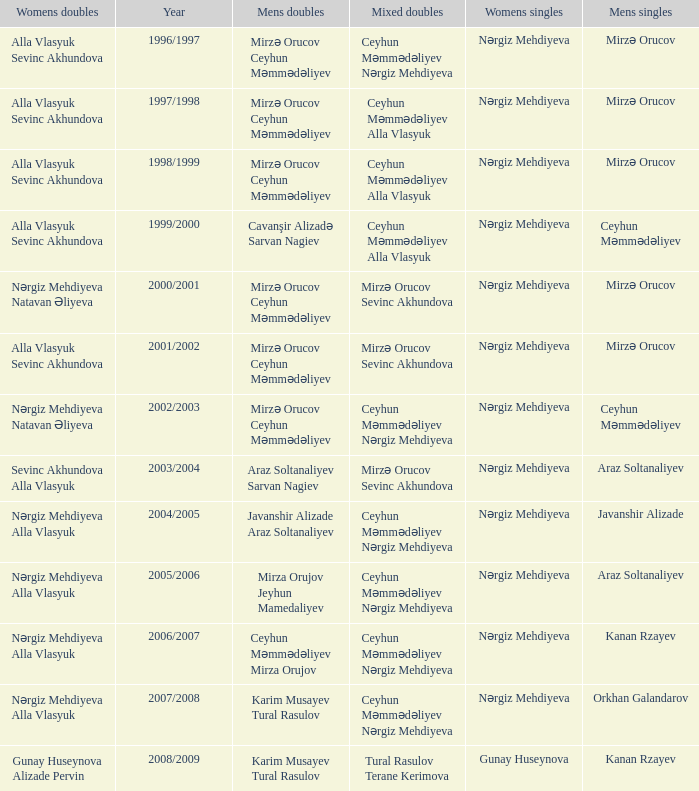Who are all the womens doubles for the year 2008/2009? Gunay Huseynova Alizade Pervin. 